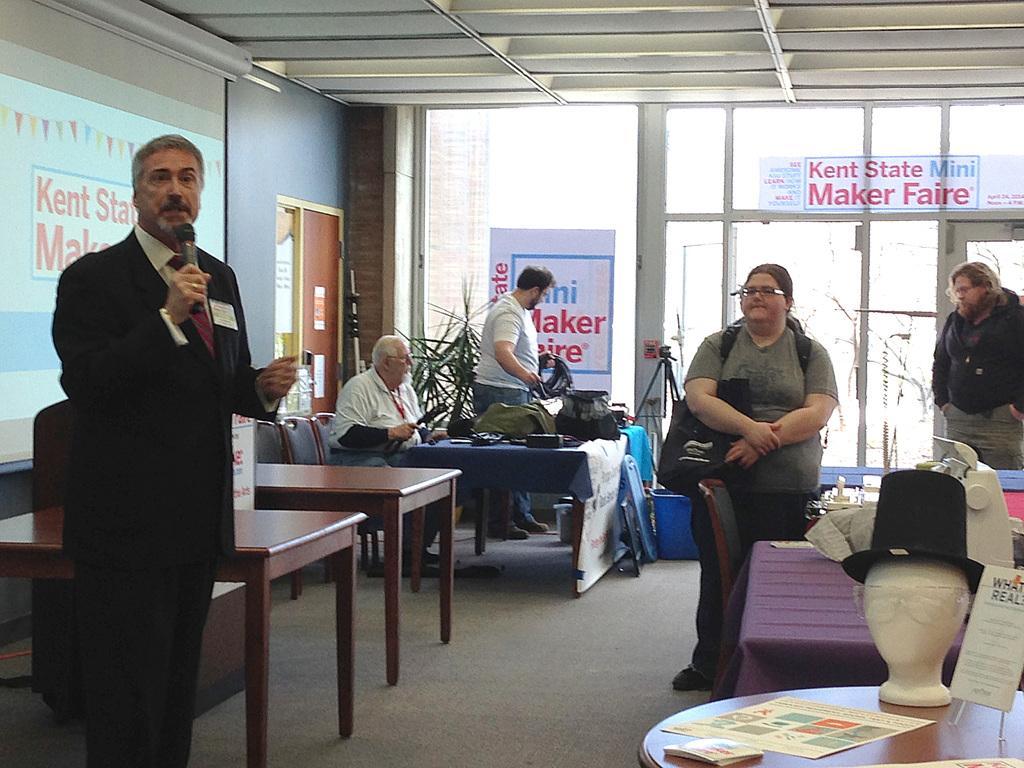Describe this image in one or two sentences. There is a man standing and talking holding a mic in his hand. There are some people standing and sitting in the chairs in the background. There is a hat on the table and a paper here. In the background there is a door. 